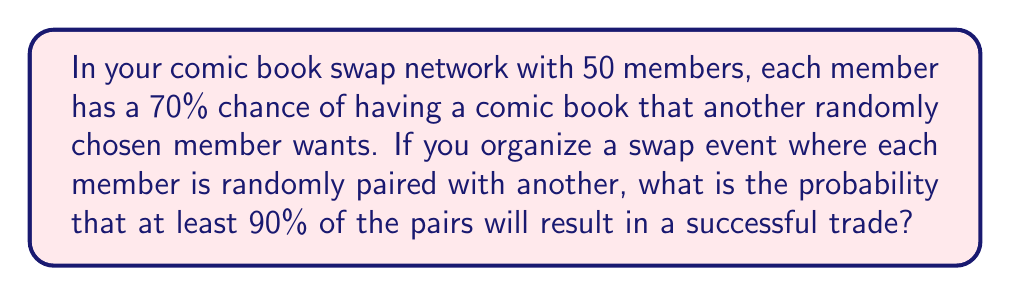Can you solve this math problem? Let's approach this step-by-step:

1) First, we need to calculate the probability of a successful trade between any two members:
   $P(\text{successful trade}) = 0.7 \times 0.7 = 0.49$

   This is because both members need to have a comic the other wants.

2) In a group of 50 members, there will be 25 pairs.

3) We want at least 90% of the pairs to have a successful trade. 
   90% of 25 is 22.5, so we're looking for 23 or more successful trades out of 25.

4) This scenario follows a binomial distribution with parameters:
   $n = 25$ (number of trials)
   $p = 0.49$ (probability of success for each trial)

5) We need to calculate:

   $$P(X \geq 23) = 1 - P(X \leq 22)$$

   where $X$ is the number of successful trades.

6) Using the binomial probability formula:

   $$P(X \leq 22) = \sum_{k=0}^{22} \binom{25}{k} (0.49)^k (0.51)^{25-k}$$

7) This calculation is complex to do by hand, so we would typically use statistical software or a calculator with binomial probability functions.

8) Using such a tool, we find:

   $P(X \leq 22) \approx 0.9992$

9) Therefore:

   $P(X \geq 23) = 1 - P(X \leq 22) \approx 1 - 0.9992 = 0.0008$
Answer: 0.0008 or 0.08% 